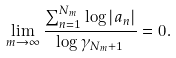Convert formula to latex. <formula><loc_0><loc_0><loc_500><loc_500>\lim _ { m \to \infty } \frac { \sum _ { n = 1 } ^ { N _ { m } } \log | a _ { n } | } { \log \gamma _ { N _ { m } + 1 } } = 0 .</formula> 